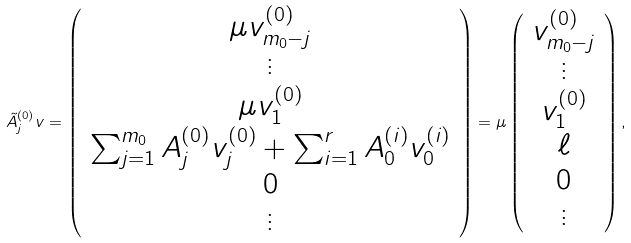Convert formula to latex. <formula><loc_0><loc_0><loc_500><loc_500>\tilde { A } ^ { ( 0 ) } _ { j } v = \left ( \begin{array} { c } \mu v ^ { ( 0 ) } _ { m _ { 0 } - j } \\ \vdots \\ \mu v ^ { ( 0 ) } _ { 1 } \\ \sum _ { j = 1 } ^ { m _ { 0 } } A ^ { ( 0 ) } _ { j } v ^ { ( 0 ) } _ { j } + \sum _ { i = 1 } ^ { r } A ^ { ( i ) } _ { 0 } v ^ { ( i ) } _ { 0 } \\ 0 \\ \vdots \end{array} \right ) = \mu \left ( \begin{array} { c } v ^ { ( 0 ) } _ { m _ { 0 } - j } \\ \vdots \\ v ^ { ( 0 ) } _ { 1 } \\ \ell \\ 0 \\ \vdots \end{array} \right ) ,</formula> 